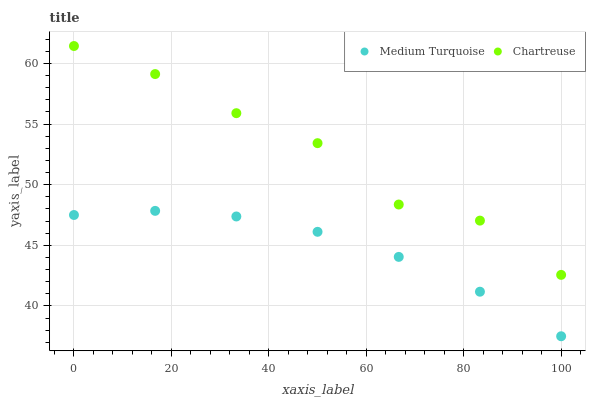Does Medium Turquoise have the minimum area under the curve?
Answer yes or no. Yes. Does Chartreuse have the maximum area under the curve?
Answer yes or no. Yes. Does Medium Turquoise have the maximum area under the curve?
Answer yes or no. No. Is Medium Turquoise the smoothest?
Answer yes or no. Yes. Is Chartreuse the roughest?
Answer yes or no. Yes. Is Medium Turquoise the roughest?
Answer yes or no. No. Does Medium Turquoise have the lowest value?
Answer yes or no. Yes. Does Chartreuse have the highest value?
Answer yes or no. Yes. Does Medium Turquoise have the highest value?
Answer yes or no. No. Is Medium Turquoise less than Chartreuse?
Answer yes or no. Yes. Is Chartreuse greater than Medium Turquoise?
Answer yes or no. Yes. Does Medium Turquoise intersect Chartreuse?
Answer yes or no. No. 